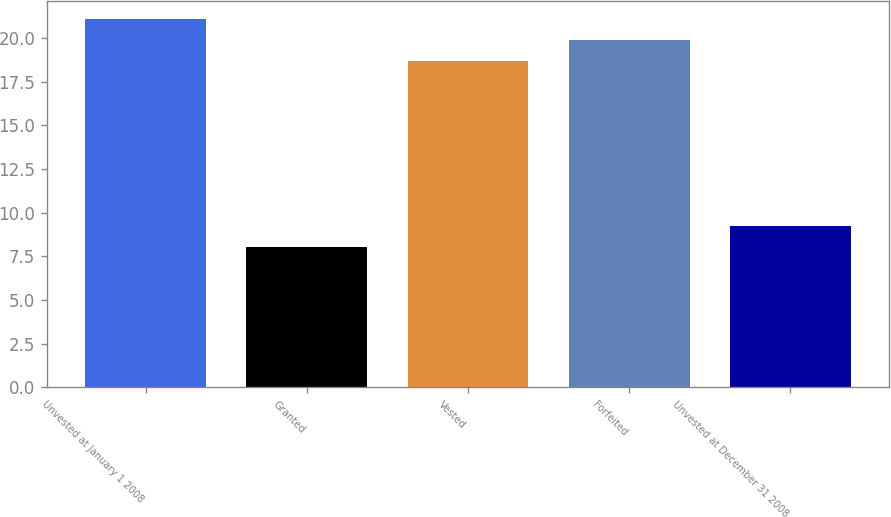Convert chart to OTSL. <chart><loc_0><loc_0><loc_500><loc_500><bar_chart><fcel>Unvested at January 1 2008<fcel>Granted<fcel>Vested<fcel>Forfeited<fcel>Unvested at December 31 2008<nl><fcel>21.09<fcel>8.04<fcel>18.67<fcel>19.88<fcel>9.25<nl></chart> 